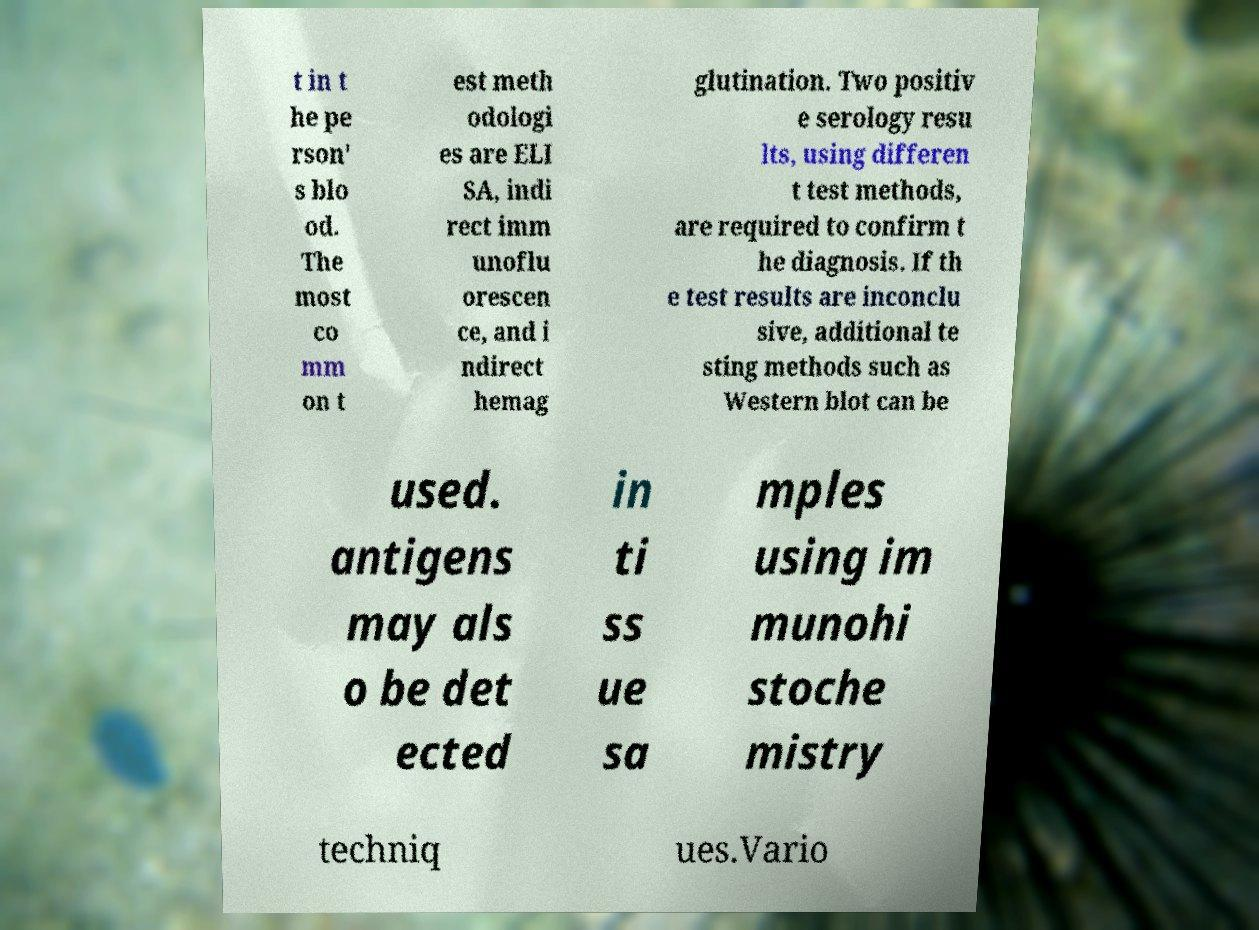Please identify and transcribe the text found in this image. t in t he pe rson' s blo od. The most co mm on t est meth odologi es are ELI SA, indi rect imm unoflu orescen ce, and i ndirect hemag glutination. Two positiv e serology resu lts, using differen t test methods, are required to confirm t he diagnosis. If th e test results are inconclu sive, additional te sting methods such as Western blot can be used. antigens may als o be det ected in ti ss ue sa mples using im munohi stoche mistry techniq ues.Vario 